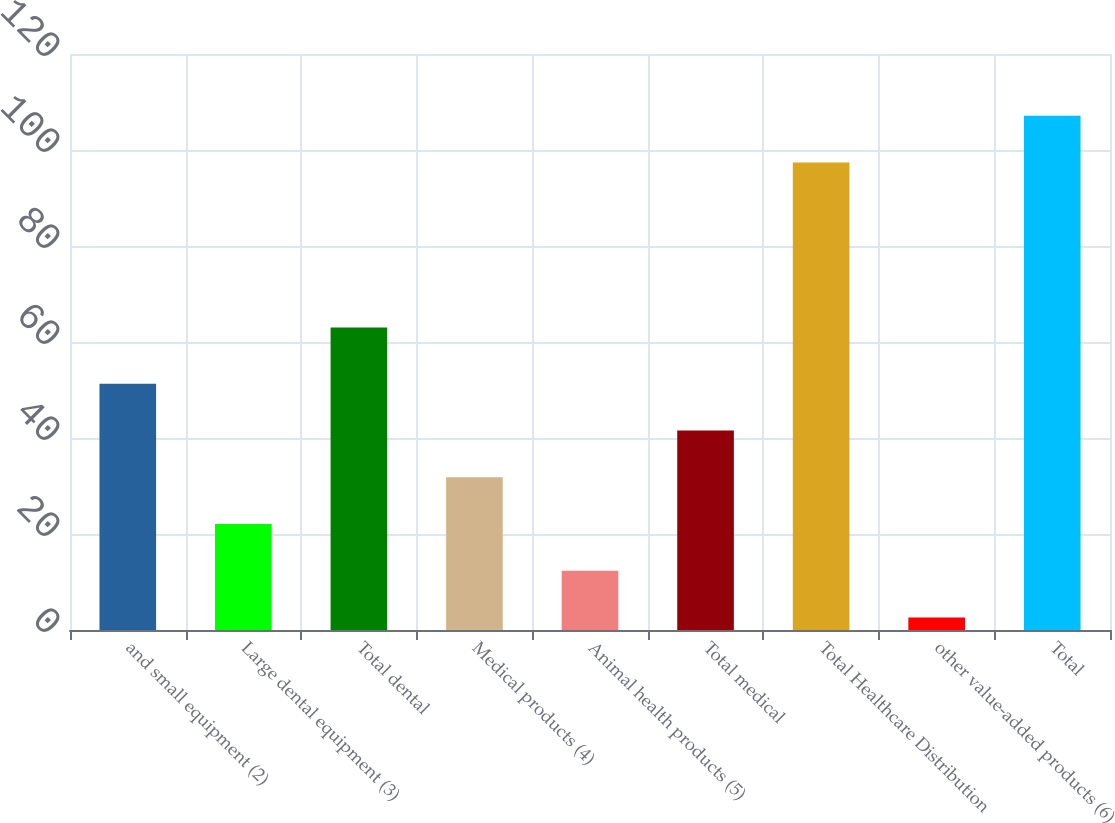Convert chart. <chart><loc_0><loc_0><loc_500><loc_500><bar_chart><fcel>and small equipment (2)<fcel>Large dental equipment (3)<fcel>Total dental<fcel>Medical products (4)<fcel>Animal health products (5)<fcel>Total medical<fcel>Total Healthcare Distribution<fcel>other value-added products (6)<fcel>Total<nl><fcel>51.3<fcel>22.08<fcel>63<fcel>31.82<fcel>12.34<fcel>41.56<fcel>97.4<fcel>2.6<fcel>107.14<nl></chart> 